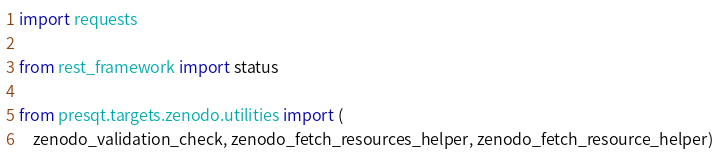<code> <loc_0><loc_0><loc_500><loc_500><_Python_>import requests

from rest_framework import status

from presqt.targets.zenodo.utilities import (
    zenodo_validation_check, zenodo_fetch_resources_helper, zenodo_fetch_resource_helper)</code> 